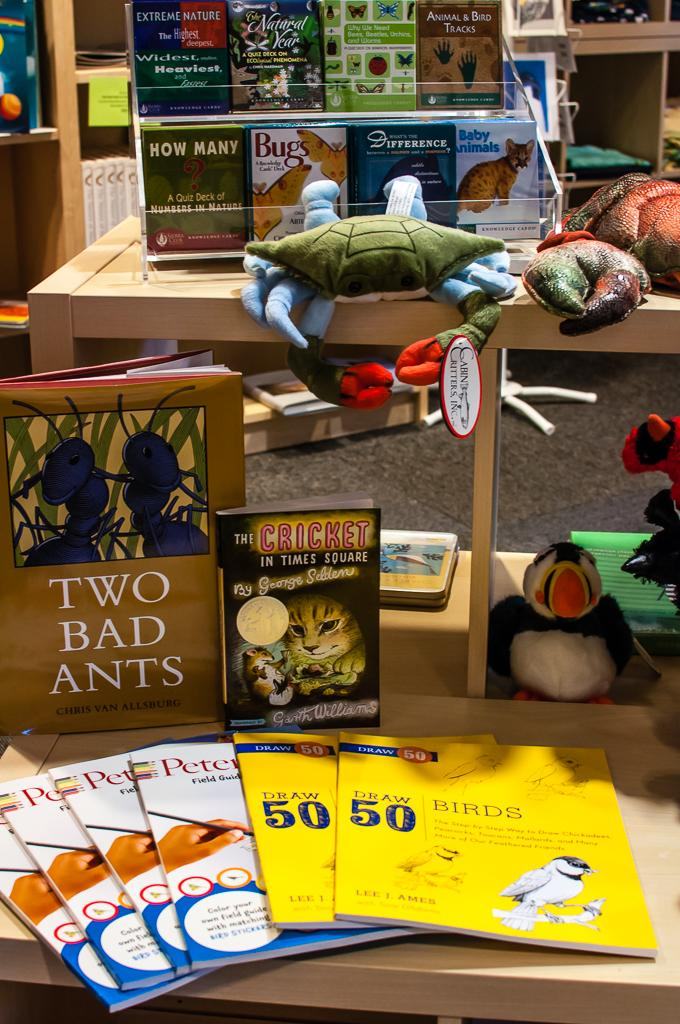<image>
Offer a succinct explanation of the picture presented. Books about animals are displayed on the shelf. 